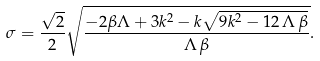<formula> <loc_0><loc_0><loc_500><loc_500>\sigma = \frac { \sqrt { 2 } } { 2 } \sqrt { { \frac { - 2 \beta \Lambda + 3 k ^ { 2 } - k \sqrt { 9 k ^ { 2 } - 1 2 \, \Lambda \, \beta } } { \Lambda \, \beta } } } .</formula> 